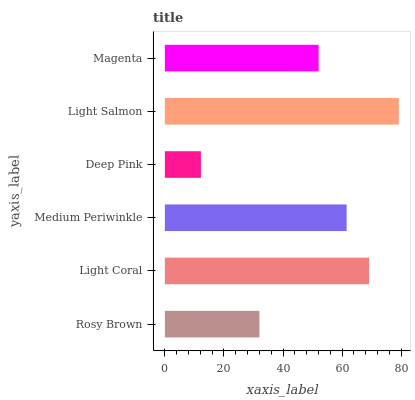Is Deep Pink the minimum?
Answer yes or no. Yes. Is Light Salmon the maximum?
Answer yes or no. Yes. Is Light Coral the minimum?
Answer yes or no. No. Is Light Coral the maximum?
Answer yes or no. No. Is Light Coral greater than Rosy Brown?
Answer yes or no. Yes. Is Rosy Brown less than Light Coral?
Answer yes or no. Yes. Is Rosy Brown greater than Light Coral?
Answer yes or no. No. Is Light Coral less than Rosy Brown?
Answer yes or no. No. Is Medium Periwinkle the high median?
Answer yes or no. Yes. Is Magenta the low median?
Answer yes or no. Yes. Is Magenta the high median?
Answer yes or no. No. Is Light Salmon the low median?
Answer yes or no. No. 